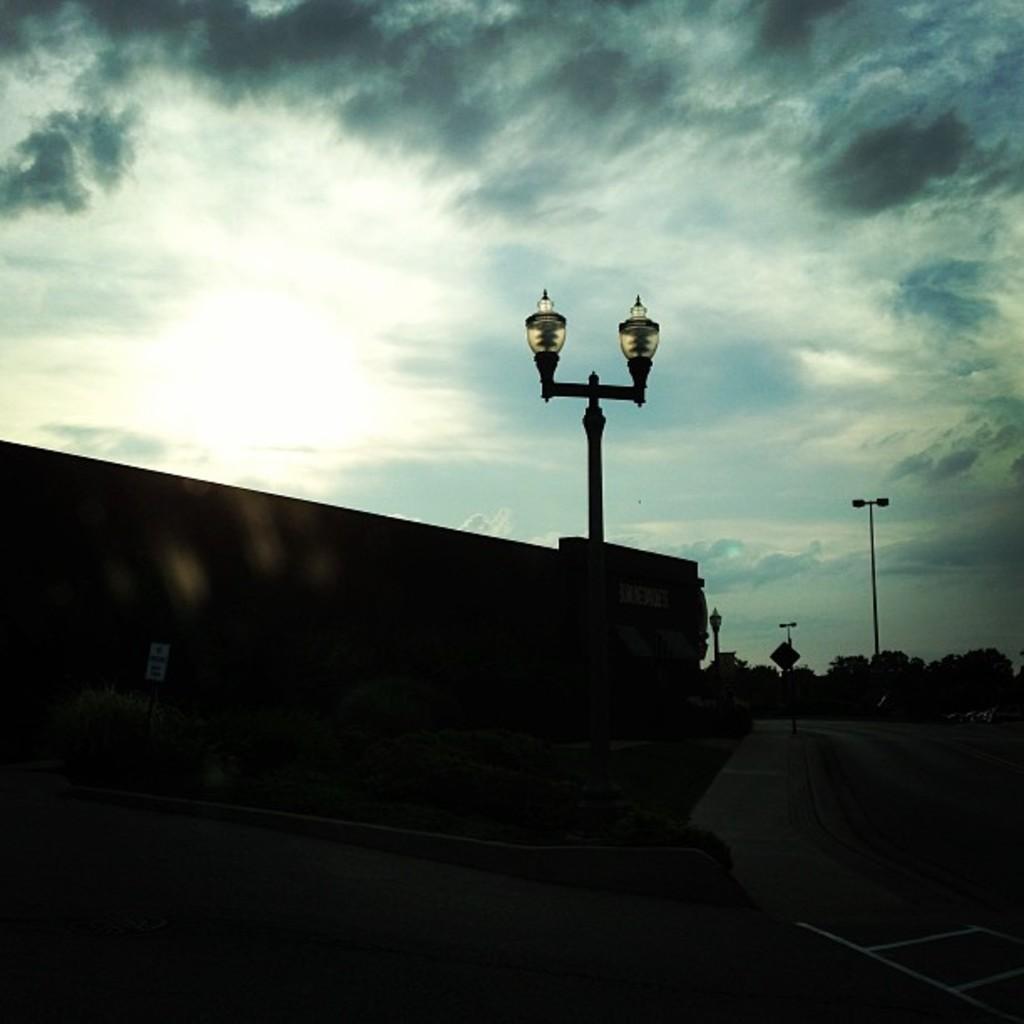Could you give a brief overview of what you see in this image? In the image there is a lamp post on the wall. This picture seems to be clicked on a road. In the above there is sky with clouds and in the background there are trees. 